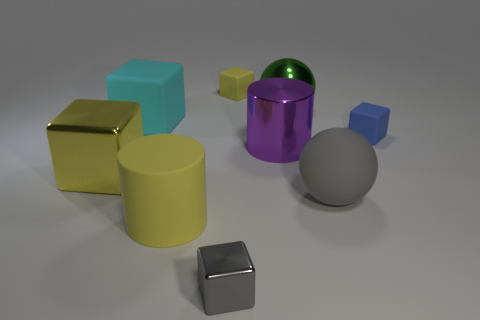What material is the big thing that is the same color as the big matte cylinder?
Make the answer very short. Metal. There is a gray thing that is made of the same material as the large purple object; what is its size?
Give a very brief answer. Small. How many rubber things are cylinders or green things?
Ensure brevity in your answer.  1. What size is the gray matte object?
Your response must be concise. Large. Is the green thing the same size as the cyan rubber object?
Ensure brevity in your answer.  Yes. There is a yellow cube that is behind the big yellow cube; what is its material?
Offer a very short reply. Rubber. What material is the gray object that is the same shape as the small yellow rubber object?
Keep it short and to the point. Metal. Is there a tiny gray block that is left of the rubber cube that is left of the tiny yellow thing?
Offer a very short reply. No. Does the tiny blue matte object have the same shape as the large gray thing?
Give a very brief answer. No. What is the shape of the yellow object that is made of the same material as the large purple cylinder?
Your answer should be compact. Cube. 